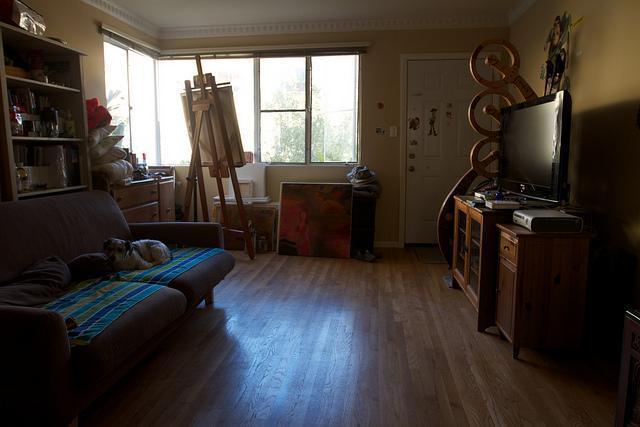How many windows?
Give a very brief answer. 6. How many tvs are there?
Give a very brief answer. 1. How many people are shown?
Give a very brief answer. 0. 